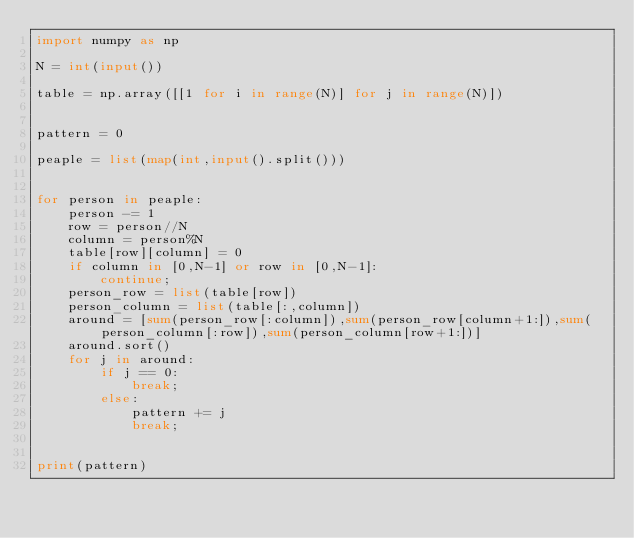<code> <loc_0><loc_0><loc_500><loc_500><_Python_>import numpy as np

N = int(input())

table = np.array([[1 for i in range(N)] for j in range(N)])


pattern = 0

peaple = list(map(int,input().split()))


for person in peaple:
    person -= 1
    row = person//N
    column = person%N
    table[row][column] = 0
    if column in [0,N-1] or row in [0,N-1]:
        continue;
    person_row = list(table[row])
    person_column = list(table[:,column])
    around = [sum(person_row[:column]),sum(person_row[column+1:]),sum(person_column[:row]),sum(person_column[row+1:])]
    around.sort()
    for j in around:
        if j == 0:
            break;
        else:
            pattern += j
            break;


print(pattern)</code> 